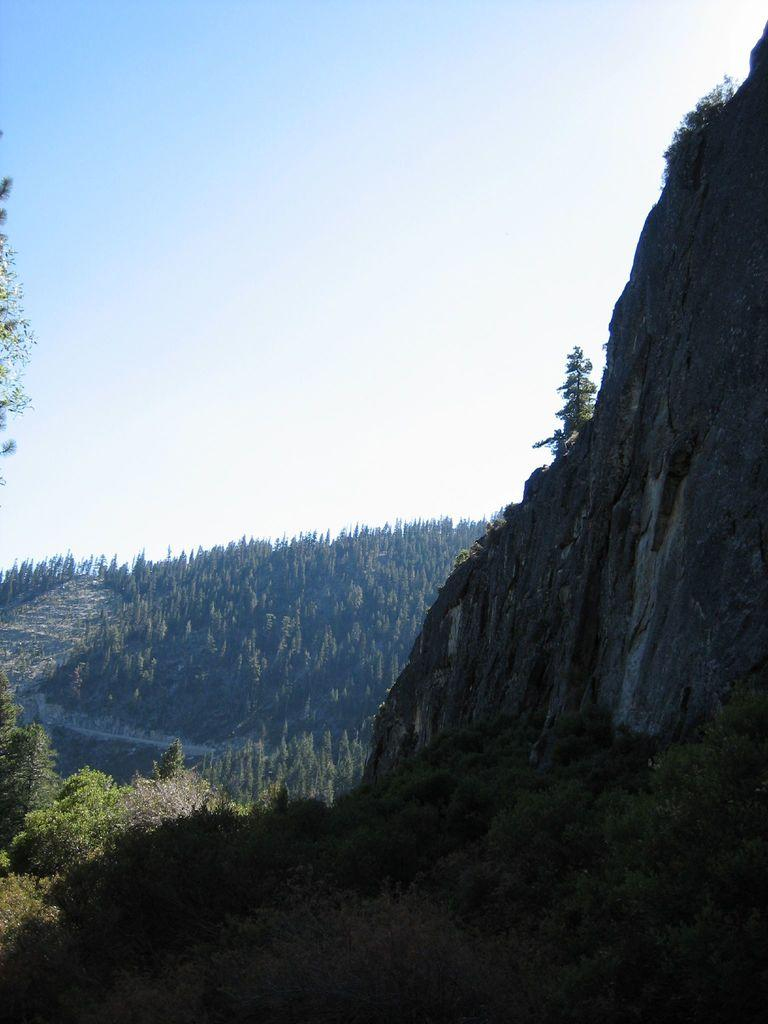Where was the picture taken? The picture was taken in the outskirts. What type of natural environment is visible in the image? There are many trees and hills in the image. What is visible at the top of the image? The sky is visible at the top of the image. What type of patch is being sewn onto the lead's uniform in the image? There is no patch or lead present in the image; it features a natural landscape with trees and hills. 